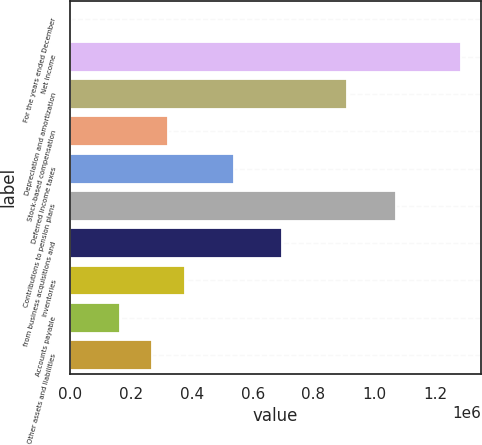<chart> <loc_0><loc_0><loc_500><loc_500><bar_chart><fcel>For the years ended December<fcel>Net income<fcel>Depreciation and amortization<fcel>Stock-based compensation<fcel>Deferred income taxes<fcel>Contributions to pension plans<fcel>from business acquisitions and<fcel>Inventories<fcel>Accounts payable<fcel>Other assets and liabilities<nl><fcel>2005<fcel>1.28599e+06<fcel>911491<fcel>323000<fcel>536997<fcel>1.07199e+06<fcel>697495<fcel>376499<fcel>162503<fcel>269501<nl></chart> 